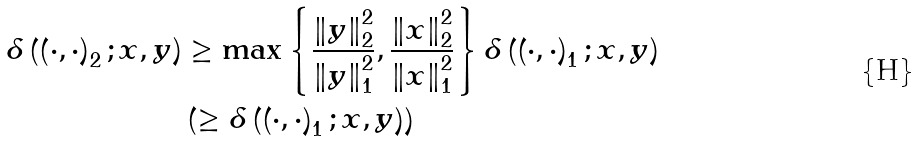Convert formula to latex. <formula><loc_0><loc_0><loc_500><loc_500>\delta \left ( \left ( \cdot , \cdot \right ) _ { 2 } ; x , y \right ) & \geq \max \left \{ \frac { \left \| y \right \| _ { 2 } ^ { 2 } } { \left \| y \right \| _ { 1 } ^ { 2 } } , \frac { \left \| x \right \| _ { 2 } ^ { 2 } } { \left \| x \right \| _ { 1 } ^ { 2 } } \right \} \delta \left ( \left ( \cdot , \cdot \right ) _ { 1 } ; x , y \right ) \\ & \left ( \geq \delta \left ( \left ( \cdot , \cdot \right ) _ { 1 } ; x , y \right ) \right )</formula> 